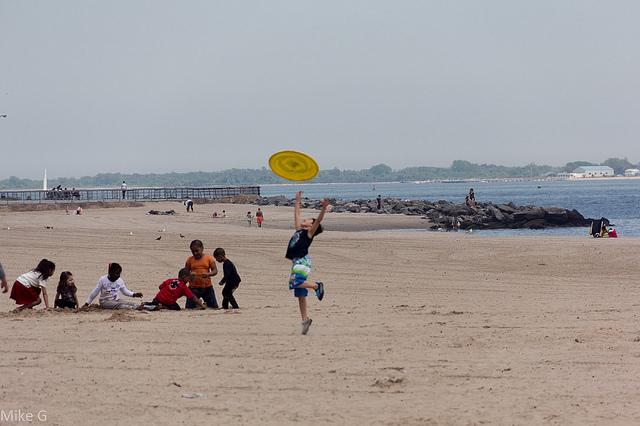What type of pattern is the boy's jacket?
Keep it brief. None. Are most of the people in this photo having fun?
Give a very brief answer. Yes. What are the children on the left digging in?
Keep it brief. Sand. What is the child catching?
Short answer required. Frisbee. 